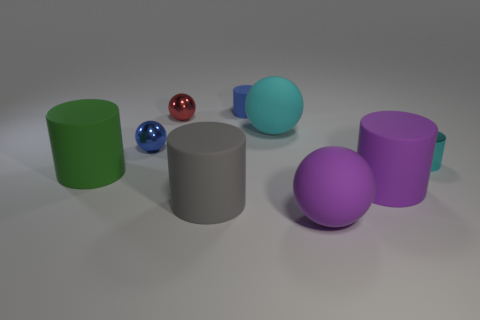Is the big gray cylinder made of the same material as the tiny red ball on the left side of the small cyan thing?
Ensure brevity in your answer.  No. Do the small rubber thing and the tiny sphere that is in front of the big cyan sphere have the same color?
Make the answer very short. Yes. What is the material of the cylinder that is to the left of the blue thing that is in front of the blue rubber cylinder?
Make the answer very short. Rubber. What number of rubber spheres are the same color as the tiny metal cylinder?
Give a very brief answer. 1. Are there the same number of big gray rubber objects on the left side of the gray cylinder and blue spheres in front of the green thing?
Your response must be concise. Yes. What is the color of the large sphere that is in front of the tiny blue object that is in front of the rubber sphere that is behind the big purple cylinder?
Offer a very short reply. Purple. What number of rubber things are both in front of the shiny cylinder and to the left of the large purple matte sphere?
Provide a succinct answer. 2. There is a tiny cylinder that is behind the metallic cylinder; is it the same color as the metal ball to the left of the small red shiny ball?
Provide a short and direct response. Yes. What is the size of the purple rubber object that is the same shape as the blue rubber thing?
Provide a short and direct response. Large. Are there any cyan metallic objects on the left side of the small blue matte object?
Offer a very short reply. No. 